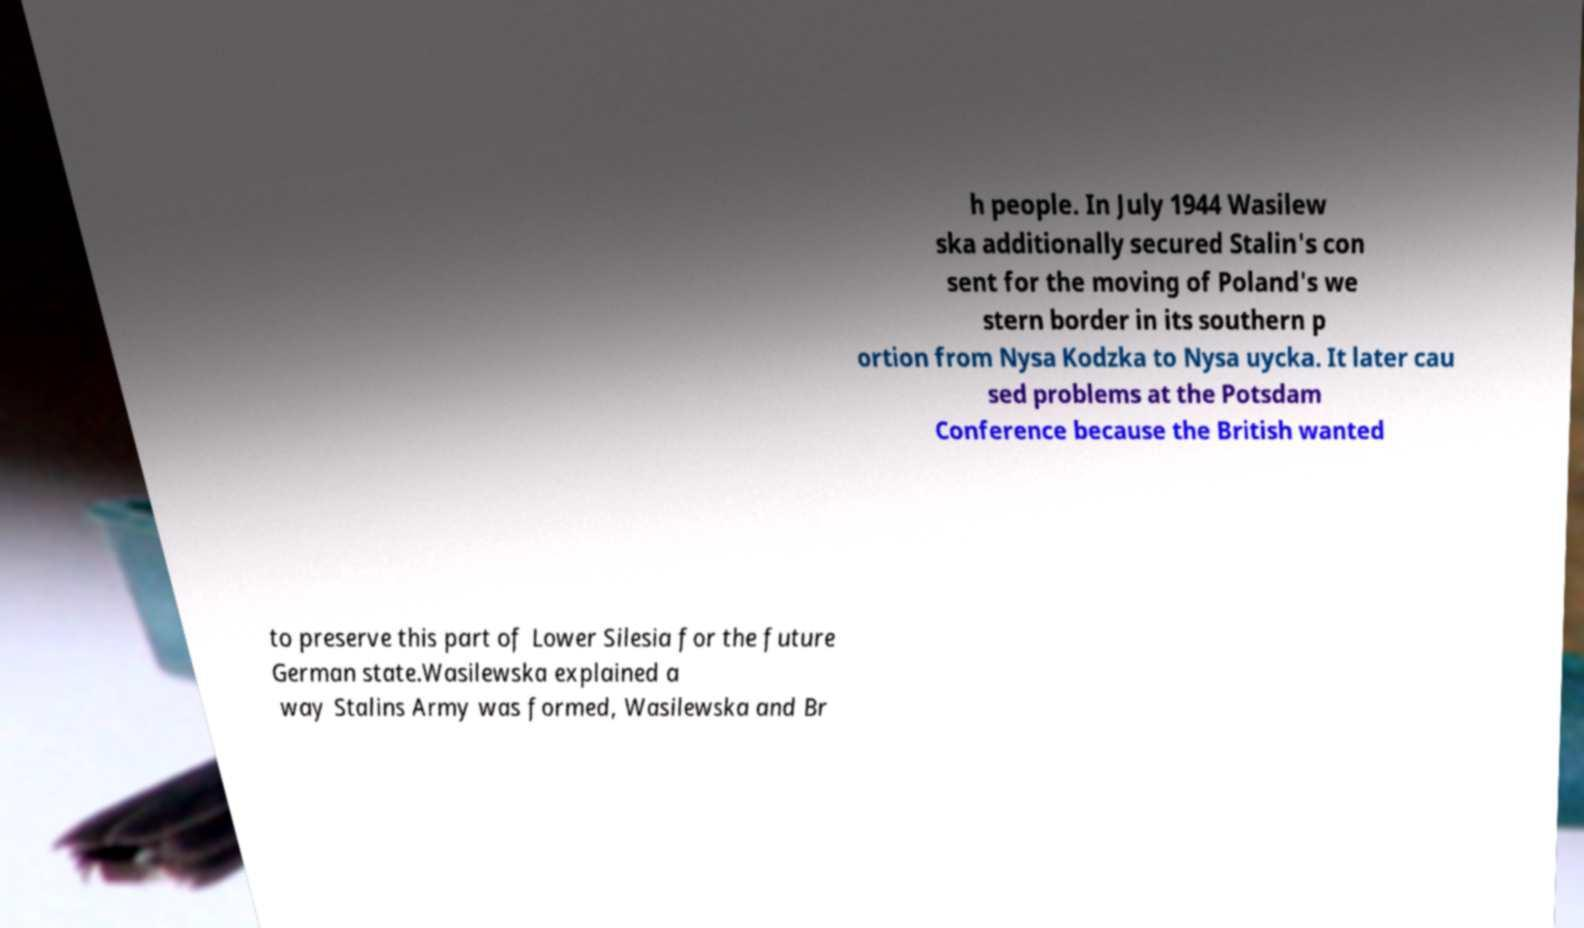Could you extract and type out the text from this image? h people. In July 1944 Wasilew ska additionally secured Stalin's con sent for the moving of Poland's we stern border in its southern p ortion from Nysa Kodzka to Nysa uycka. It later cau sed problems at the Potsdam Conference because the British wanted to preserve this part of Lower Silesia for the future German state.Wasilewska explained a way Stalins Army was formed, Wasilewska and Br 